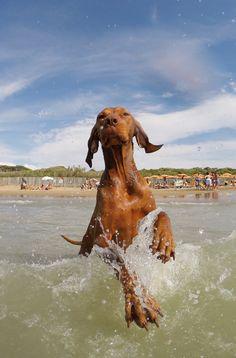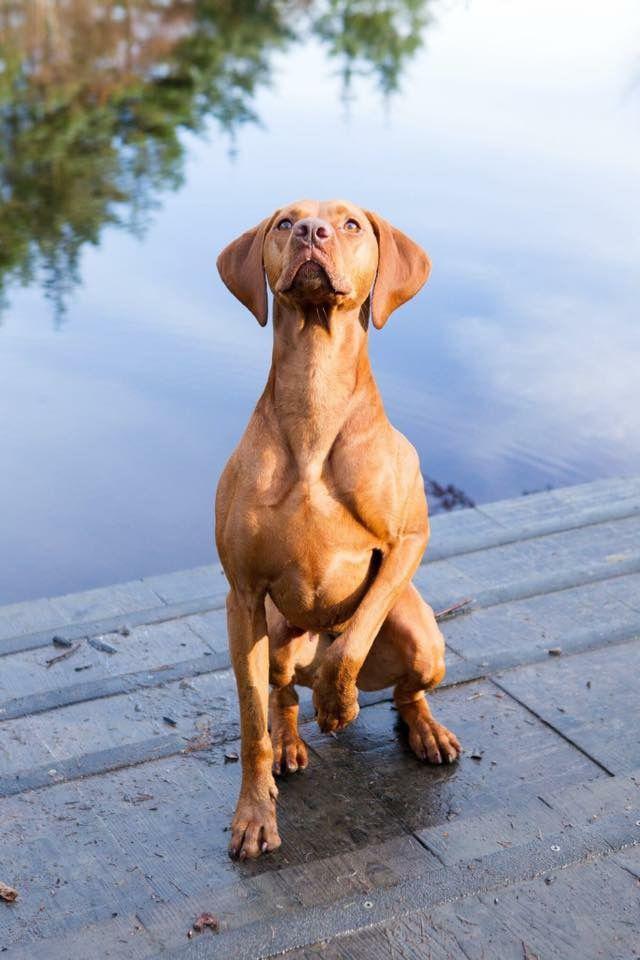The first image is the image on the left, the second image is the image on the right. Analyze the images presented: Is the assertion "One red-orange dog is splashing through the water in one image, and the other image features at least one red-orange dog on a surface above the water." valid? Answer yes or no. Yes. The first image is the image on the left, the second image is the image on the right. For the images shown, is this caption "The left image contains at least two dogs." true? Answer yes or no. No. 